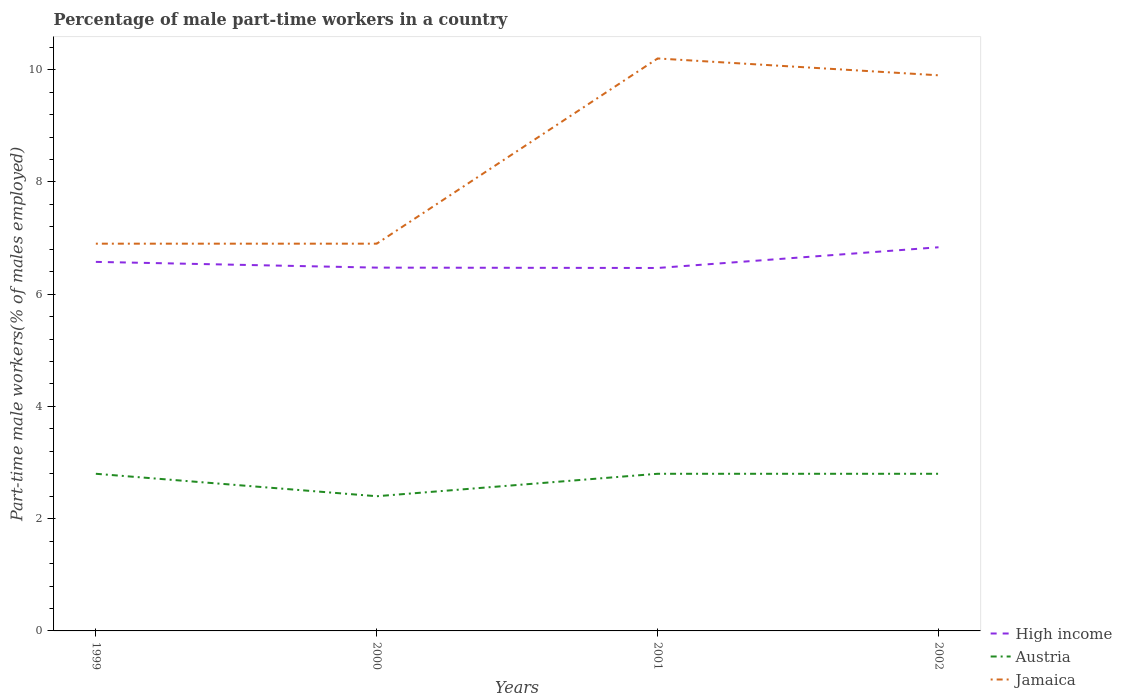How many different coloured lines are there?
Give a very brief answer. 3. Does the line corresponding to Jamaica intersect with the line corresponding to High income?
Provide a succinct answer. No. Across all years, what is the maximum percentage of male part-time workers in Jamaica?
Make the answer very short. 6.9. In which year was the percentage of male part-time workers in High income maximum?
Offer a terse response. 2001. What is the total percentage of male part-time workers in High income in the graph?
Give a very brief answer. -0.36. What is the difference between the highest and the second highest percentage of male part-time workers in High income?
Make the answer very short. 0.37. How many years are there in the graph?
Your answer should be very brief. 4. What is the difference between two consecutive major ticks on the Y-axis?
Ensure brevity in your answer.  2. Does the graph contain any zero values?
Offer a very short reply. No. Where does the legend appear in the graph?
Give a very brief answer. Bottom right. What is the title of the graph?
Keep it short and to the point. Percentage of male part-time workers in a country. Does "Nigeria" appear as one of the legend labels in the graph?
Your answer should be compact. No. What is the label or title of the Y-axis?
Make the answer very short. Part-time male workers(% of males employed). What is the Part-time male workers(% of males employed) in High income in 1999?
Ensure brevity in your answer.  6.58. What is the Part-time male workers(% of males employed) in Austria in 1999?
Provide a succinct answer. 2.8. What is the Part-time male workers(% of males employed) in Jamaica in 1999?
Offer a very short reply. 6.9. What is the Part-time male workers(% of males employed) of High income in 2000?
Ensure brevity in your answer.  6.47. What is the Part-time male workers(% of males employed) of Austria in 2000?
Make the answer very short. 2.4. What is the Part-time male workers(% of males employed) of Jamaica in 2000?
Offer a terse response. 6.9. What is the Part-time male workers(% of males employed) in High income in 2001?
Ensure brevity in your answer.  6.47. What is the Part-time male workers(% of males employed) in Austria in 2001?
Give a very brief answer. 2.8. What is the Part-time male workers(% of males employed) in Jamaica in 2001?
Offer a terse response. 10.2. What is the Part-time male workers(% of males employed) in High income in 2002?
Make the answer very short. 6.84. What is the Part-time male workers(% of males employed) in Austria in 2002?
Ensure brevity in your answer.  2.8. What is the Part-time male workers(% of males employed) in Jamaica in 2002?
Make the answer very short. 9.9. Across all years, what is the maximum Part-time male workers(% of males employed) in High income?
Provide a succinct answer. 6.84. Across all years, what is the maximum Part-time male workers(% of males employed) in Austria?
Make the answer very short. 2.8. Across all years, what is the maximum Part-time male workers(% of males employed) in Jamaica?
Provide a succinct answer. 10.2. Across all years, what is the minimum Part-time male workers(% of males employed) in High income?
Your answer should be compact. 6.47. Across all years, what is the minimum Part-time male workers(% of males employed) in Austria?
Your response must be concise. 2.4. Across all years, what is the minimum Part-time male workers(% of males employed) of Jamaica?
Your response must be concise. 6.9. What is the total Part-time male workers(% of males employed) of High income in the graph?
Provide a short and direct response. 26.35. What is the total Part-time male workers(% of males employed) in Austria in the graph?
Provide a succinct answer. 10.8. What is the total Part-time male workers(% of males employed) of Jamaica in the graph?
Give a very brief answer. 33.9. What is the difference between the Part-time male workers(% of males employed) in High income in 1999 and that in 2000?
Your answer should be very brief. 0.1. What is the difference between the Part-time male workers(% of males employed) of High income in 1999 and that in 2001?
Offer a very short reply. 0.11. What is the difference between the Part-time male workers(% of males employed) in High income in 1999 and that in 2002?
Give a very brief answer. -0.26. What is the difference between the Part-time male workers(% of males employed) in Austria in 1999 and that in 2002?
Make the answer very short. 0. What is the difference between the Part-time male workers(% of males employed) of Jamaica in 1999 and that in 2002?
Provide a succinct answer. -3. What is the difference between the Part-time male workers(% of males employed) of High income in 2000 and that in 2001?
Provide a short and direct response. 0.01. What is the difference between the Part-time male workers(% of males employed) in High income in 2000 and that in 2002?
Provide a succinct answer. -0.36. What is the difference between the Part-time male workers(% of males employed) of Austria in 2000 and that in 2002?
Your response must be concise. -0.4. What is the difference between the Part-time male workers(% of males employed) of Jamaica in 2000 and that in 2002?
Provide a short and direct response. -3. What is the difference between the Part-time male workers(% of males employed) of High income in 2001 and that in 2002?
Your answer should be very brief. -0.37. What is the difference between the Part-time male workers(% of males employed) of Austria in 2001 and that in 2002?
Provide a short and direct response. 0. What is the difference between the Part-time male workers(% of males employed) of High income in 1999 and the Part-time male workers(% of males employed) of Austria in 2000?
Your response must be concise. 4.18. What is the difference between the Part-time male workers(% of males employed) in High income in 1999 and the Part-time male workers(% of males employed) in Jamaica in 2000?
Your answer should be very brief. -0.32. What is the difference between the Part-time male workers(% of males employed) in Austria in 1999 and the Part-time male workers(% of males employed) in Jamaica in 2000?
Your response must be concise. -4.1. What is the difference between the Part-time male workers(% of males employed) of High income in 1999 and the Part-time male workers(% of males employed) of Austria in 2001?
Your answer should be compact. 3.78. What is the difference between the Part-time male workers(% of males employed) of High income in 1999 and the Part-time male workers(% of males employed) of Jamaica in 2001?
Keep it short and to the point. -3.62. What is the difference between the Part-time male workers(% of males employed) of High income in 1999 and the Part-time male workers(% of males employed) of Austria in 2002?
Give a very brief answer. 3.78. What is the difference between the Part-time male workers(% of males employed) in High income in 1999 and the Part-time male workers(% of males employed) in Jamaica in 2002?
Make the answer very short. -3.32. What is the difference between the Part-time male workers(% of males employed) in Austria in 1999 and the Part-time male workers(% of males employed) in Jamaica in 2002?
Your answer should be very brief. -7.1. What is the difference between the Part-time male workers(% of males employed) in High income in 2000 and the Part-time male workers(% of males employed) in Austria in 2001?
Give a very brief answer. 3.67. What is the difference between the Part-time male workers(% of males employed) of High income in 2000 and the Part-time male workers(% of males employed) of Jamaica in 2001?
Keep it short and to the point. -3.73. What is the difference between the Part-time male workers(% of males employed) in High income in 2000 and the Part-time male workers(% of males employed) in Austria in 2002?
Offer a terse response. 3.67. What is the difference between the Part-time male workers(% of males employed) in High income in 2000 and the Part-time male workers(% of males employed) in Jamaica in 2002?
Provide a succinct answer. -3.43. What is the difference between the Part-time male workers(% of males employed) in Austria in 2000 and the Part-time male workers(% of males employed) in Jamaica in 2002?
Provide a succinct answer. -7.5. What is the difference between the Part-time male workers(% of males employed) of High income in 2001 and the Part-time male workers(% of males employed) of Austria in 2002?
Make the answer very short. 3.67. What is the difference between the Part-time male workers(% of males employed) of High income in 2001 and the Part-time male workers(% of males employed) of Jamaica in 2002?
Provide a short and direct response. -3.43. What is the average Part-time male workers(% of males employed) in High income per year?
Offer a terse response. 6.59. What is the average Part-time male workers(% of males employed) in Jamaica per year?
Give a very brief answer. 8.47. In the year 1999, what is the difference between the Part-time male workers(% of males employed) of High income and Part-time male workers(% of males employed) of Austria?
Keep it short and to the point. 3.78. In the year 1999, what is the difference between the Part-time male workers(% of males employed) of High income and Part-time male workers(% of males employed) of Jamaica?
Your answer should be very brief. -0.32. In the year 2000, what is the difference between the Part-time male workers(% of males employed) in High income and Part-time male workers(% of males employed) in Austria?
Give a very brief answer. 4.07. In the year 2000, what is the difference between the Part-time male workers(% of males employed) in High income and Part-time male workers(% of males employed) in Jamaica?
Ensure brevity in your answer.  -0.43. In the year 2000, what is the difference between the Part-time male workers(% of males employed) in Austria and Part-time male workers(% of males employed) in Jamaica?
Your answer should be very brief. -4.5. In the year 2001, what is the difference between the Part-time male workers(% of males employed) of High income and Part-time male workers(% of males employed) of Austria?
Make the answer very short. 3.67. In the year 2001, what is the difference between the Part-time male workers(% of males employed) of High income and Part-time male workers(% of males employed) of Jamaica?
Ensure brevity in your answer.  -3.73. In the year 2001, what is the difference between the Part-time male workers(% of males employed) in Austria and Part-time male workers(% of males employed) in Jamaica?
Ensure brevity in your answer.  -7.4. In the year 2002, what is the difference between the Part-time male workers(% of males employed) in High income and Part-time male workers(% of males employed) in Austria?
Your response must be concise. 4.04. In the year 2002, what is the difference between the Part-time male workers(% of males employed) of High income and Part-time male workers(% of males employed) of Jamaica?
Give a very brief answer. -3.06. In the year 2002, what is the difference between the Part-time male workers(% of males employed) of Austria and Part-time male workers(% of males employed) of Jamaica?
Your answer should be very brief. -7.1. What is the ratio of the Part-time male workers(% of males employed) of High income in 1999 to that in 2000?
Make the answer very short. 1.02. What is the ratio of the Part-time male workers(% of males employed) in Jamaica in 1999 to that in 2000?
Your answer should be compact. 1. What is the ratio of the Part-time male workers(% of males employed) of High income in 1999 to that in 2001?
Offer a terse response. 1.02. What is the ratio of the Part-time male workers(% of males employed) of Jamaica in 1999 to that in 2001?
Provide a short and direct response. 0.68. What is the ratio of the Part-time male workers(% of males employed) in High income in 1999 to that in 2002?
Provide a short and direct response. 0.96. What is the ratio of the Part-time male workers(% of males employed) in Austria in 1999 to that in 2002?
Your answer should be compact. 1. What is the ratio of the Part-time male workers(% of males employed) of Jamaica in 1999 to that in 2002?
Offer a terse response. 0.7. What is the ratio of the Part-time male workers(% of males employed) of High income in 2000 to that in 2001?
Offer a very short reply. 1. What is the ratio of the Part-time male workers(% of males employed) of Jamaica in 2000 to that in 2001?
Your answer should be compact. 0.68. What is the ratio of the Part-time male workers(% of males employed) of High income in 2000 to that in 2002?
Provide a short and direct response. 0.95. What is the ratio of the Part-time male workers(% of males employed) in Austria in 2000 to that in 2002?
Keep it short and to the point. 0.86. What is the ratio of the Part-time male workers(% of males employed) in Jamaica in 2000 to that in 2002?
Keep it short and to the point. 0.7. What is the ratio of the Part-time male workers(% of males employed) of High income in 2001 to that in 2002?
Provide a short and direct response. 0.95. What is the ratio of the Part-time male workers(% of males employed) in Jamaica in 2001 to that in 2002?
Ensure brevity in your answer.  1.03. What is the difference between the highest and the second highest Part-time male workers(% of males employed) in High income?
Give a very brief answer. 0.26. What is the difference between the highest and the second highest Part-time male workers(% of males employed) in Austria?
Offer a very short reply. 0. What is the difference between the highest and the lowest Part-time male workers(% of males employed) in High income?
Offer a terse response. 0.37. What is the difference between the highest and the lowest Part-time male workers(% of males employed) in Austria?
Your response must be concise. 0.4. 